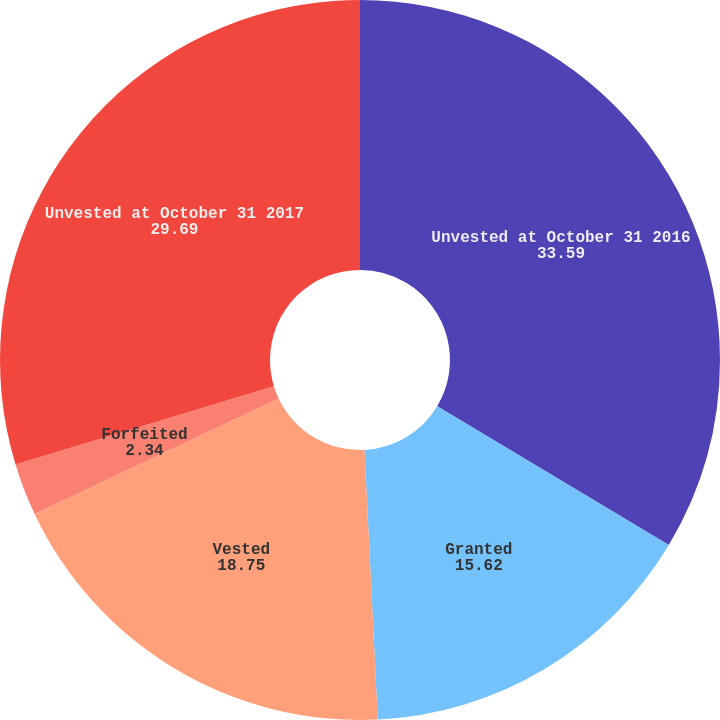<chart> <loc_0><loc_0><loc_500><loc_500><pie_chart><fcel>Unvested at October 31 2016<fcel>Granted<fcel>Vested<fcel>Forfeited<fcel>Unvested at October 31 2017<nl><fcel>33.59%<fcel>15.62%<fcel>18.75%<fcel>2.34%<fcel>29.69%<nl></chart> 